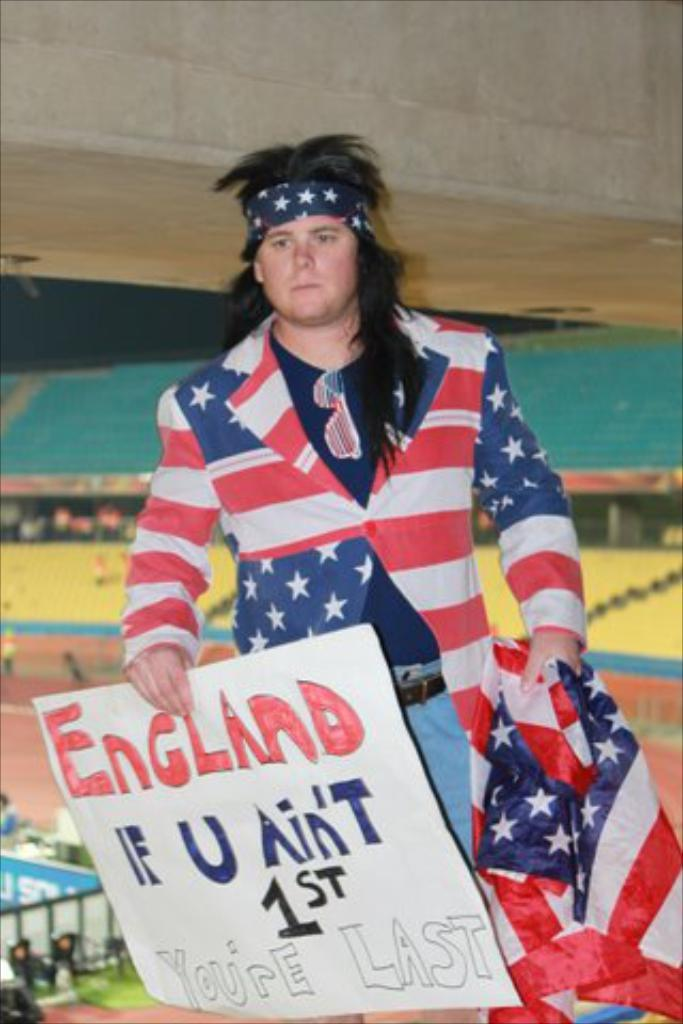Provide a one-sentence caption for the provided image. A man wearing a United States flag jacket holds a sign that says "England: If U Ain't 1st You're Last.". 